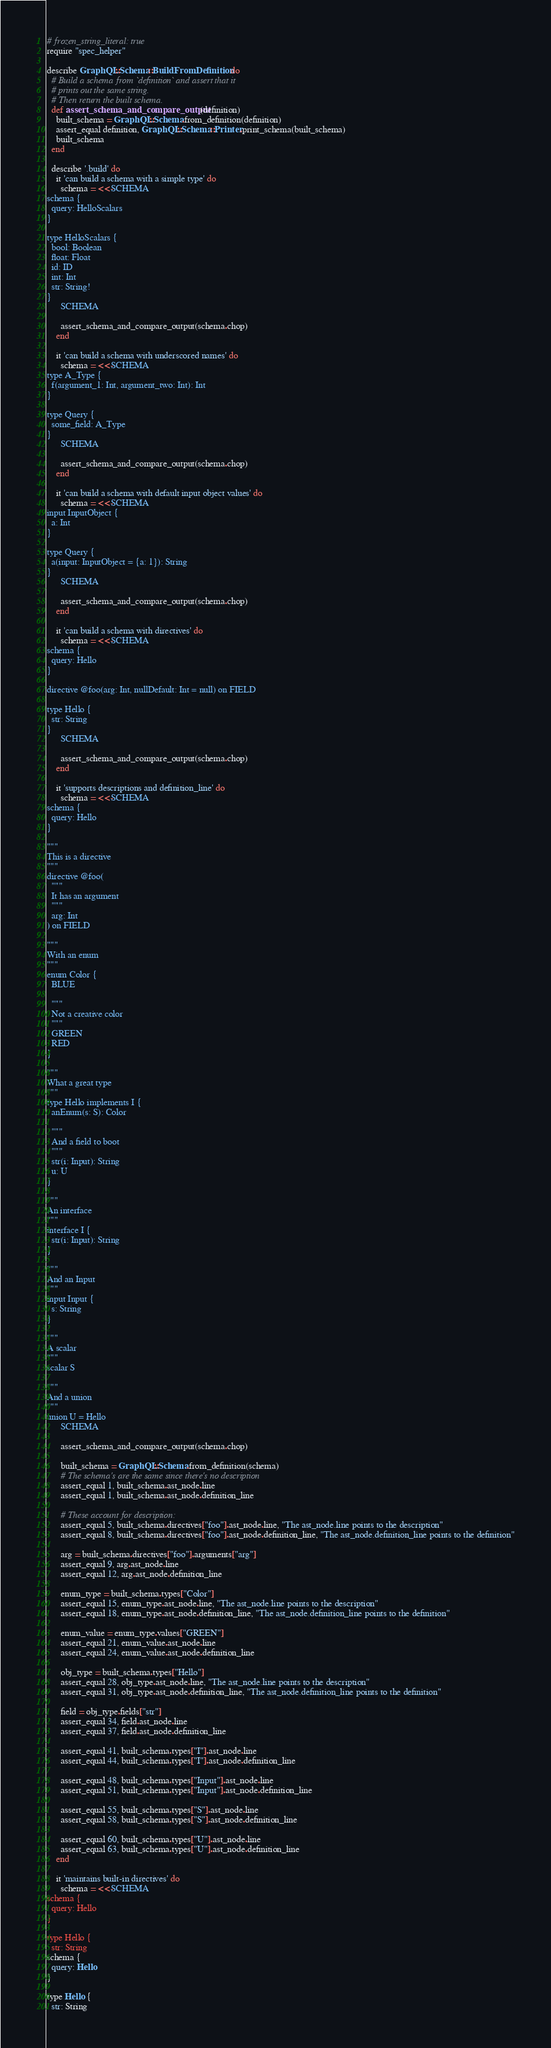Convert code to text. <code><loc_0><loc_0><loc_500><loc_500><_Ruby_># frozen_string_literal: true
require "spec_helper"

describe GraphQL::Schema::BuildFromDefinition do
  # Build a schema from `definition` and assert that it
  # prints out the same string.
  # Then return the built schema.
  def assert_schema_and_compare_output(definition)
    built_schema = GraphQL::Schema.from_definition(definition)
    assert_equal definition, GraphQL::Schema::Printer.print_schema(built_schema)
    built_schema
  end

  describe '.build' do
    it 'can build a schema with a simple type' do
      schema = <<-SCHEMA
schema {
  query: HelloScalars
}

type HelloScalars {
  bool: Boolean
  float: Float
  id: ID
  int: Int
  str: String!
}
      SCHEMA

      assert_schema_and_compare_output(schema.chop)
    end

    it 'can build a schema with underscored names' do
      schema = <<-SCHEMA
type A_Type {
  f(argument_1: Int, argument_two: Int): Int
}

type Query {
  some_field: A_Type
}
      SCHEMA

      assert_schema_and_compare_output(schema.chop)
    end

    it 'can build a schema with default input object values' do
      schema = <<-SCHEMA
input InputObject {
  a: Int
}

type Query {
  a(input: InputObject = {a: 1}): String
}
      SCHEMA

      assert_schema_and_compare_output(schema.chop)
    end

    it 'can build a schema with directives' do
      schema = <<-SCHEMA
schema {
  query: Hello
}

directive @foo(arg: Int, nullDefault: Int = null) on FIELD

type Hello {
  str: String
}
      SCHEMA

      assert_schema_and_compare_output(schema.chop)
    end

    it 'supports descriptions and definition_line' do
      schema = <<-SCHEMA
schema {
  query: Hello
}

"""
This is a directive
"""
directive @foo(
  """
  It has an argument
  """
  arg: Int
) on FIELD

"""
With an enum
"""
enum Color {
  BLUE

  """
  Not a creative color
  """
  GREEN
  RED
}

"""
What a great type
"""
type Hello implements I {
  anEnum(s: S): Color

  """
  And a field to boot
  """
  str(i: Input): String
  u: U
}

"""
An interface
"""
interface I {
  str(i: Input): String
}

"""
And an Input
"""
input Input {
  s: String
}

"""
A scalar
"""
scalar S

"""
And a union
"""
union U = Hello
      SCHEMA

      assert_schema_and_compare_output(schema.chop)

      built_schema = GraphQL::Schema.from_definition(schema)
      # The schema's are the same since there's no description
      assert_equal 1, built_schema.ast_node.line
      assert_equal 1, built_schema.ast_node.definition_line

      # These account for description:
      assert_equal 5, built_schema.directives["foo"].ast_node.line, "The ast_node.line points to the description"
      assert_equal 8, built_schema.directives["foo"].ast_node.definition_line, "The ast_node.definition_line points to the definition"

      arg = built_schema.directives["foo"].arguments["arg"]
      assert_equal 9, arg.ast_node.line
      assert_equal 12, arg.ast_node.definition_line

      enum_type = built_schema.types["Color"]
      assert_equal 15, enum_type.ast_node.line, "The ast_node.line points to the description"
      assert_equal 18, enum_type.ast_node.definition_line, "The ast_node.definition_line points to the definition"

      enum_value = enum_type.values["GREEN"]
      assert_equal 21, enum_value.ast_node.line
      assert_equal 24, enum_value.ast_node.definition_line

      obj_type = built_schema.types["Hello"]
      assert_equal 28, obj_type.ast_node.line, "The ast_node.line points to the description"
      assert_equal 31, obj_type.ast_node.definition_line, "The ast_node.definition_line points to the definition"

      field = obj_type.fields["str"]
      assert_equal 34, field.ast_node.line
      assert_equal 37, field.ast_node.definition_line

      assert_equal 41, built_schema.types["I"].ast_node.line
      assert_equal 44, built_schema.types["I"].ast_node.definition_line

      assert_equal 48, built_schema.types["Input"].ast_node.line
      assert_equal 51, built_schema.types["Input"].ast_node.definition_line

      assert_equal 55, built_schema.types["S"].ast_node.line
      assert_equal 58, built_schema.types["S"].ast_node.definition_line

      assert_equal 60, built_schema.types["U"].ast_node.line
      assert_equal 63, built_schema.types["U"].ast_node.definition_line
    end

    it 'maintains built-in directives' do
      schema = <<-SCHEMA
schema {
  query: Hello
}

type Hello {
  str: String</code> 